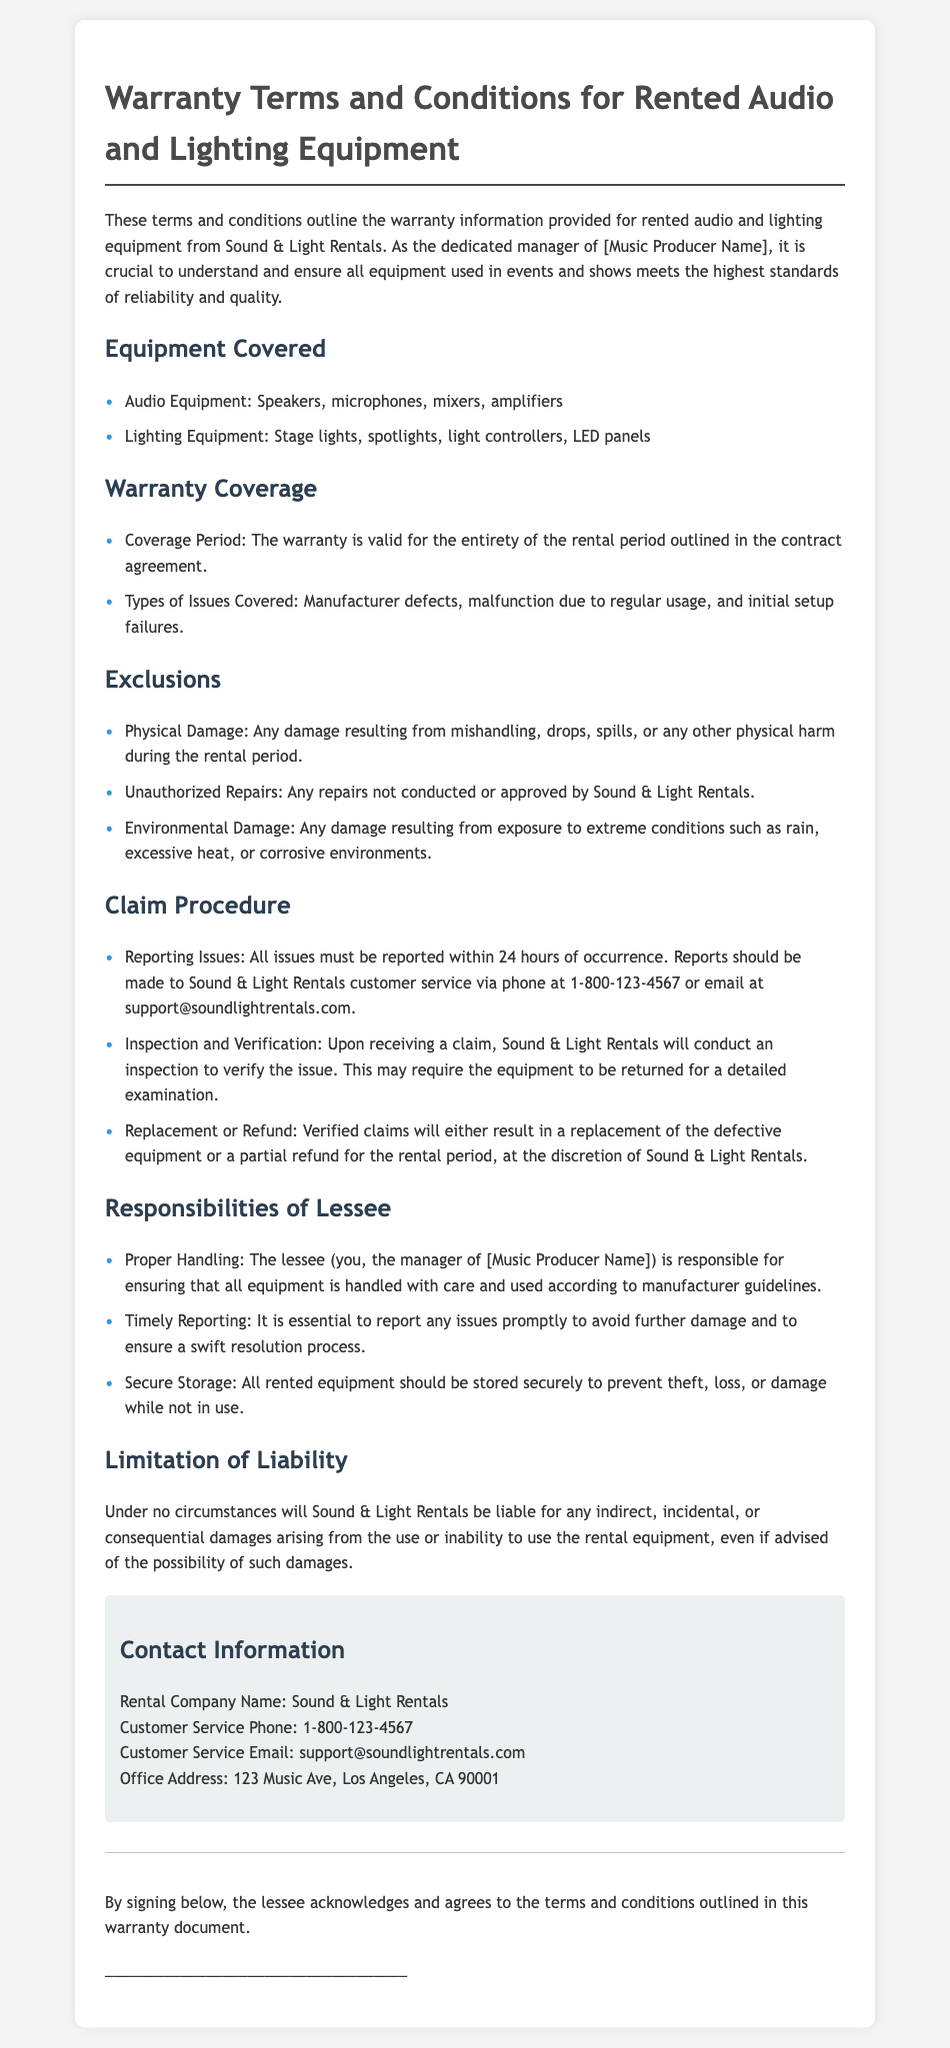What is the name of the rental company? The name of the rental company is mentioned in the contact information section of the document.
Answer: Sound & Light Rentals What types of audio equipment are covered under the warranty? The document lists specific types of audio equipment that are included in the warranty coverage section.
Answer: Speakers, microphones, mixers, amplifiers What is the duration of the warranty coverage? The duration of the warranty is specified in the warranty coverage section of the document.
Answer: Entirety of the rental period Which type of damage is excluded from the warranty? The document specifies categories of exclusions under the exclusions section.
Answer: Physical Damage What must be done within 24 hours when an issue arises? The document states the necessary action regarding reporting issues within a specific timeframe.
Answer: Reporting Issues What action can be taken for verified claims? The document outlines the potential resolutions available once a claim is verified.
Answer: Replacement or Refund Who is responsible for proper equipment handling? The document specifies which party is responsible for ensuring proper handling in the responsibilities section.
Answer: The lessee What is the customer service phone number? The phone number for customer service is provided in the contact information section.
Answer: 1-800-123-4567 